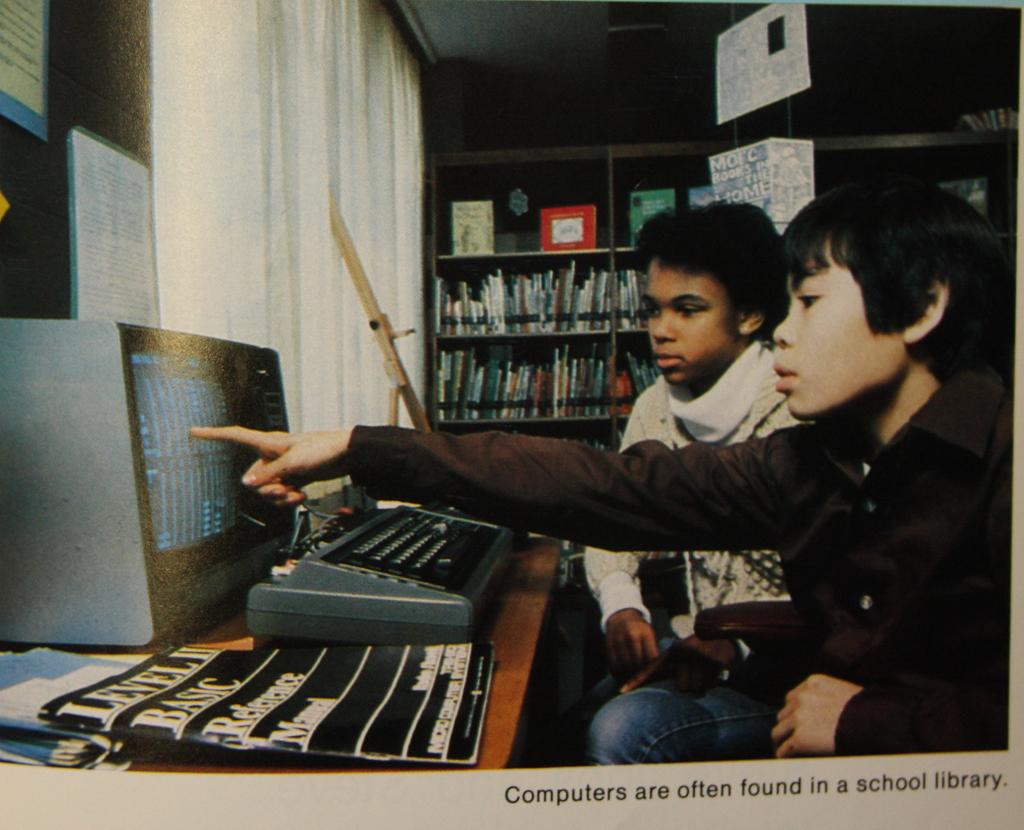Where are the computers usually in a school?
Offer a terse response. Library. What is the name of the book placed in the table?
Make the answer very short. Level ii basic reference manual. 